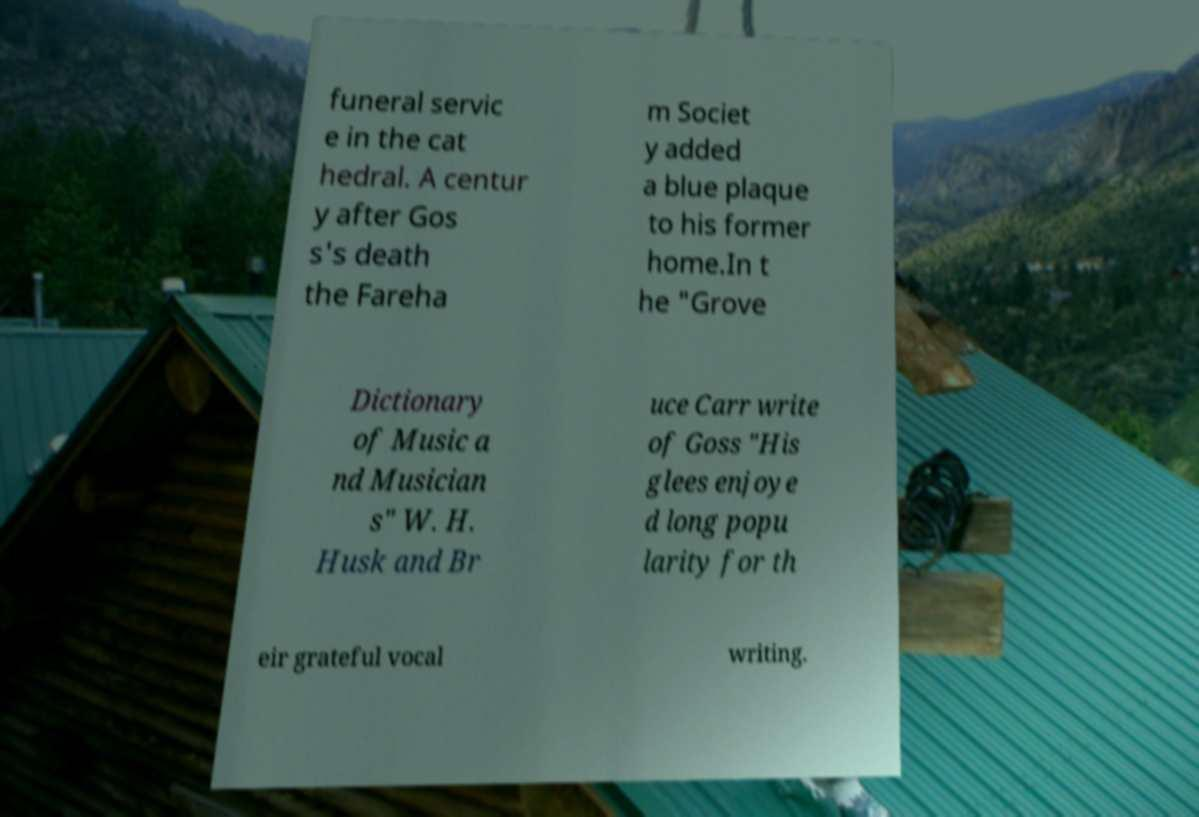Can you accurately transcribe the text from the provided image for me? funeral servic e in the cat hedral. A centur y after Gos s's death the Fareha m Societ y added a blue plaque to his former home.In t he "Grove Dictionary of Music a nd Musician s" W. H. Husk and Br uce Carr write of Goss "His glees enjoye d long popu larity for th eir grateful vocal writing. 